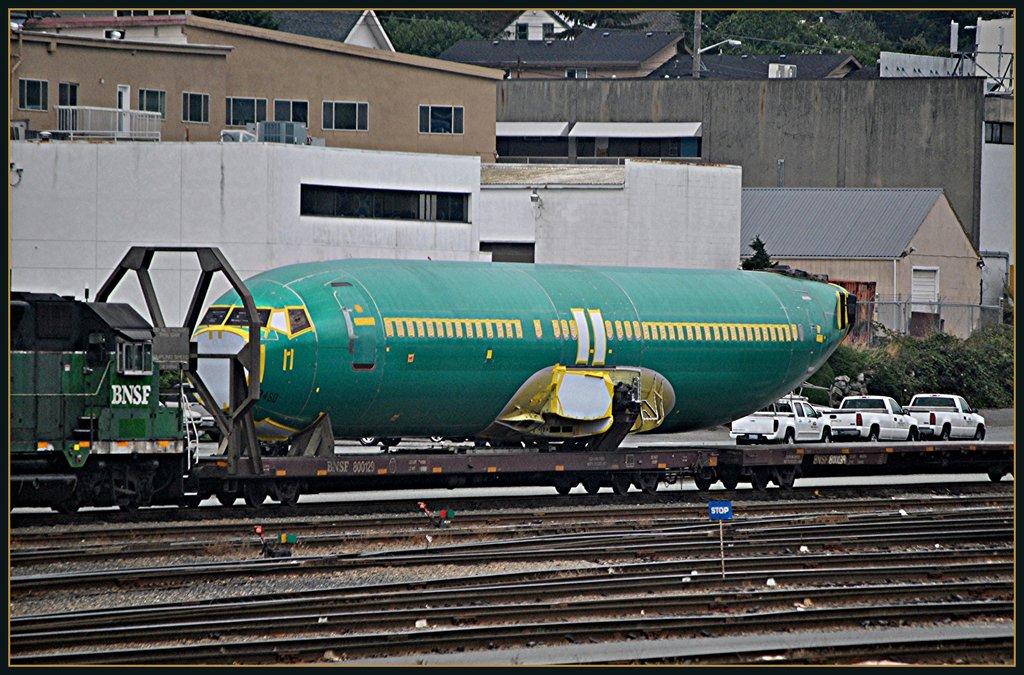This a simens mobile?
Make the answer very short. No. 